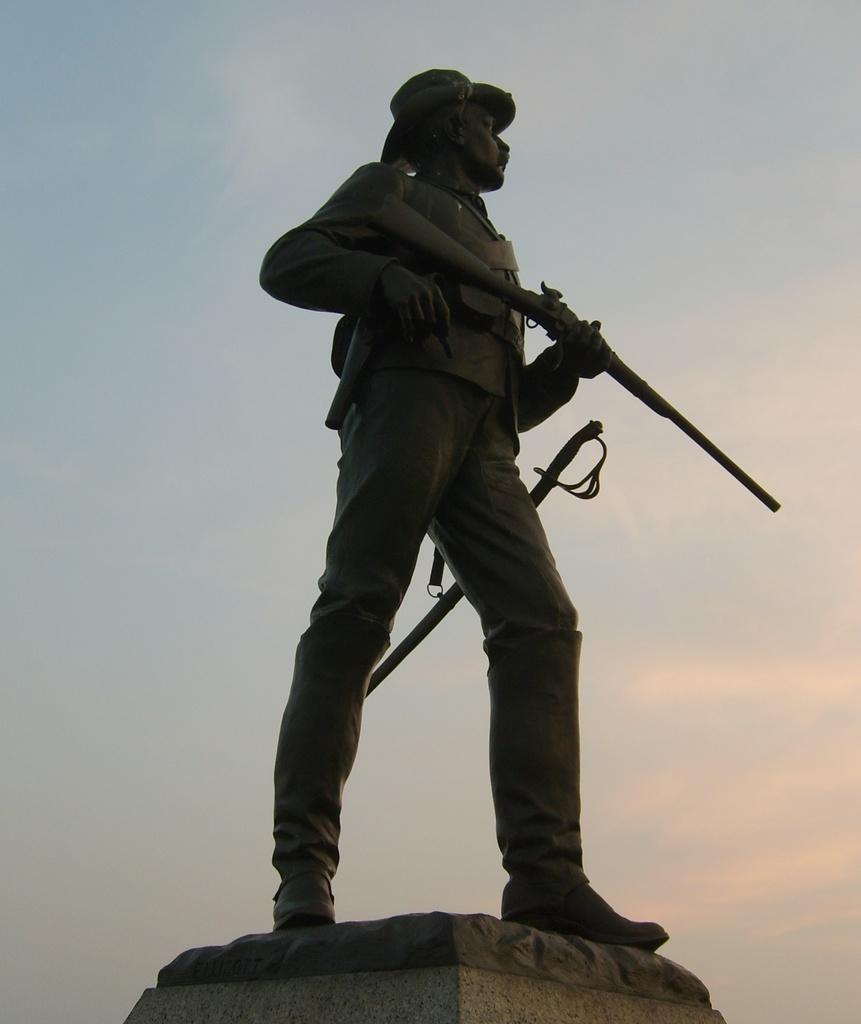Describe this image in one or two sentences. This picture contains the statue of the man in the uniform is standing. We see a rifle in his hand. In the background, we see the sky. 